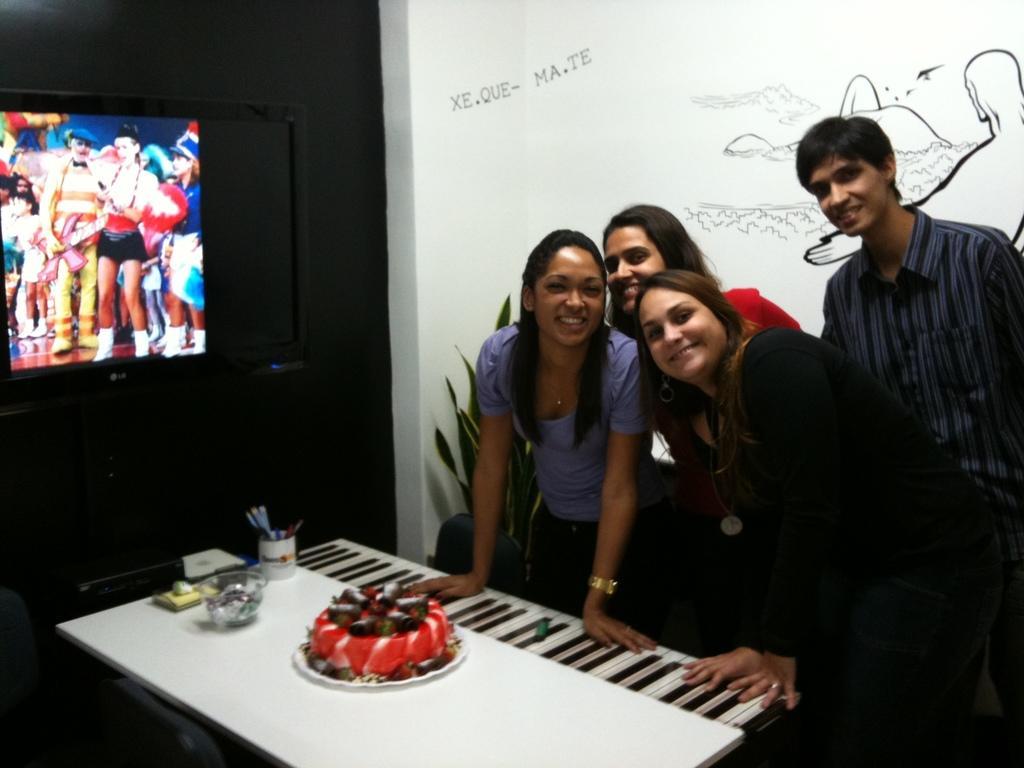In one or two sentences, can you explain what this image depicts? In the image we can see there are people standing and on the table there is a cake, there is a pen stand and beside there is a tv screen on the wall. 